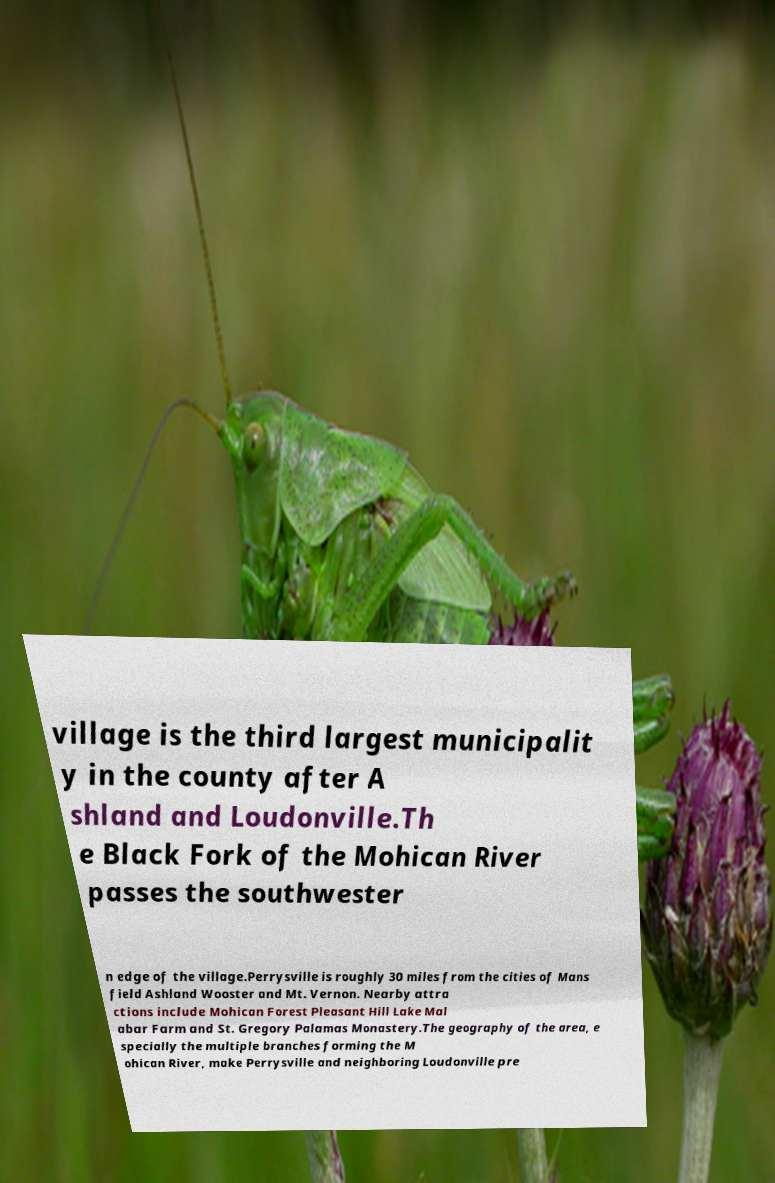What messages or text are displayed in this image? I need them in a readable, typed format. village is the third largest municipalit y in the county after A shland and Loudonville.Th e Black Fork of the Mohican River passes the southwester n edge of the village.Perrysville is roughly 30 miles from the cities of Mans field Ashland Wooster and Mt. Vernon. Nearby attra ctions include Mohican Forest Pleasant Hill Lake Mal abar Farm and St. Gregory Palamas Monastery.The geography of the area, e specially the multiple branches forming the M ohican River, make Perrysville and neighboring Loudonville pre 